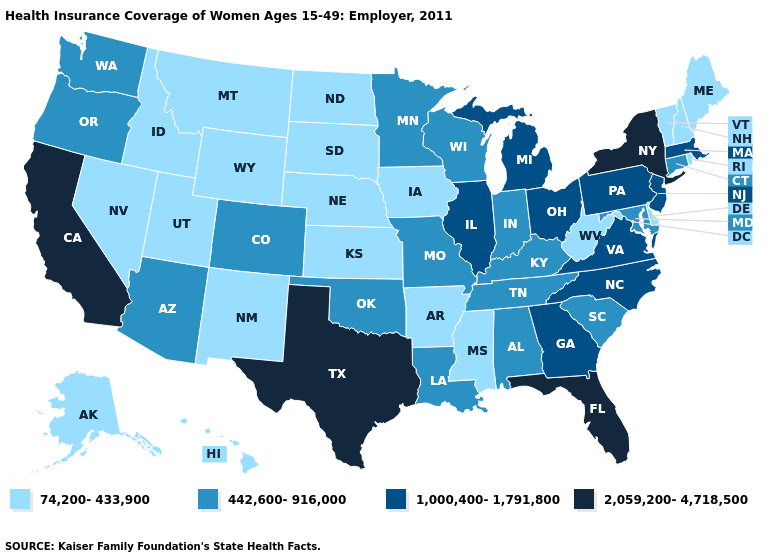What is the value of California?
Give a very brief answer. 2,059,200-4,718,500. What is the value of Alaska?
Be succinct. 74,200-433,900. Does the map have missing data?
Concise answer only. No. Name the states that have a value in the range 2,059,200-4,718,500?
Keep it brief. California, Florida, New York, Texas. Name the states that have a value in the range 1,000,400-1,791,800?
Concise answer only. Georgia, Illinois, Massachusetts, Michigan, New Jersey, North Carolina, Ohio, Pennsylvania, Virginia. Does the first symbol in the legend represent the smallest category?
Be succinct. Yes. Does the first symbol in the legend represent the smallest category?
Give a very brief answer. Yes. What is the value of Minnesota?
Be succinct. 442,600-916,000. Does Arkansas have a lower value than Virginia?
Be succinct. Yes. Which states have the highest value in the USA?
Write a very short answer. California, Florida, New York, Texas. What is the value of Washington?
Be succinct. 442,600-916,000. Which states hav the highest value in the MidWest?
Answer briefly. Illinois, Michigan, Ohio. Does Louisiana have the same value as Wyoming?
Give a very brief answer. No. Does Ohio have the lowest value in the MidWest?
Give a very brief answer. No. 